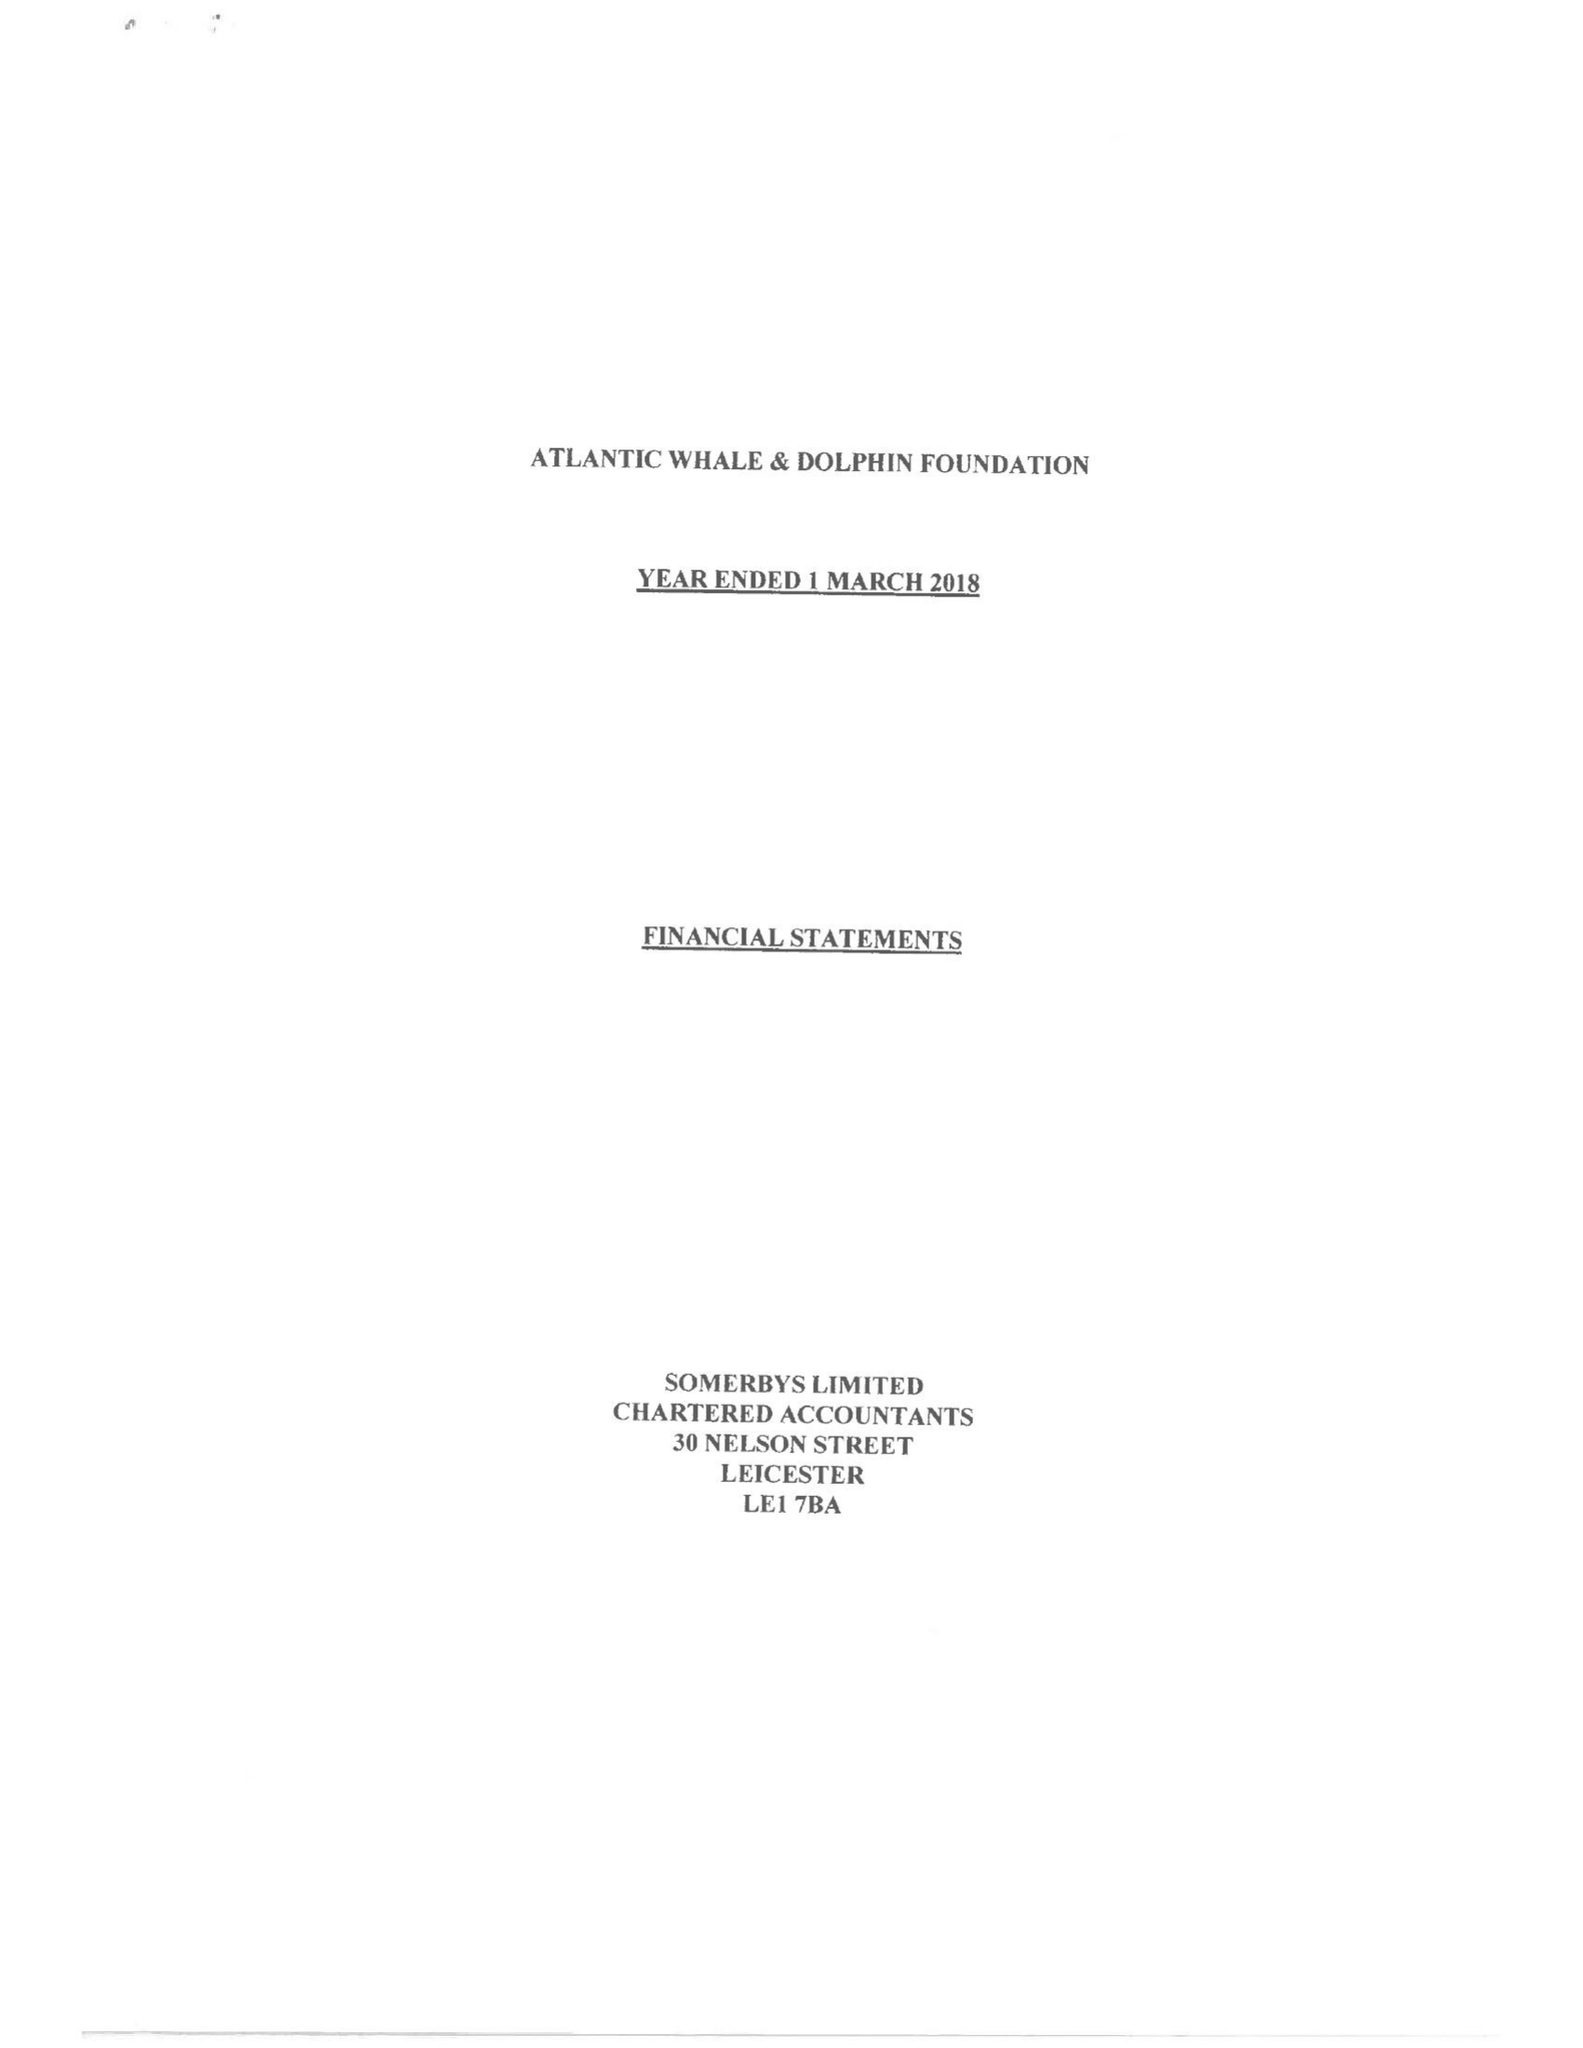What is the value for the charity_number?
Answer the question using a single word or phrase. 1167109 